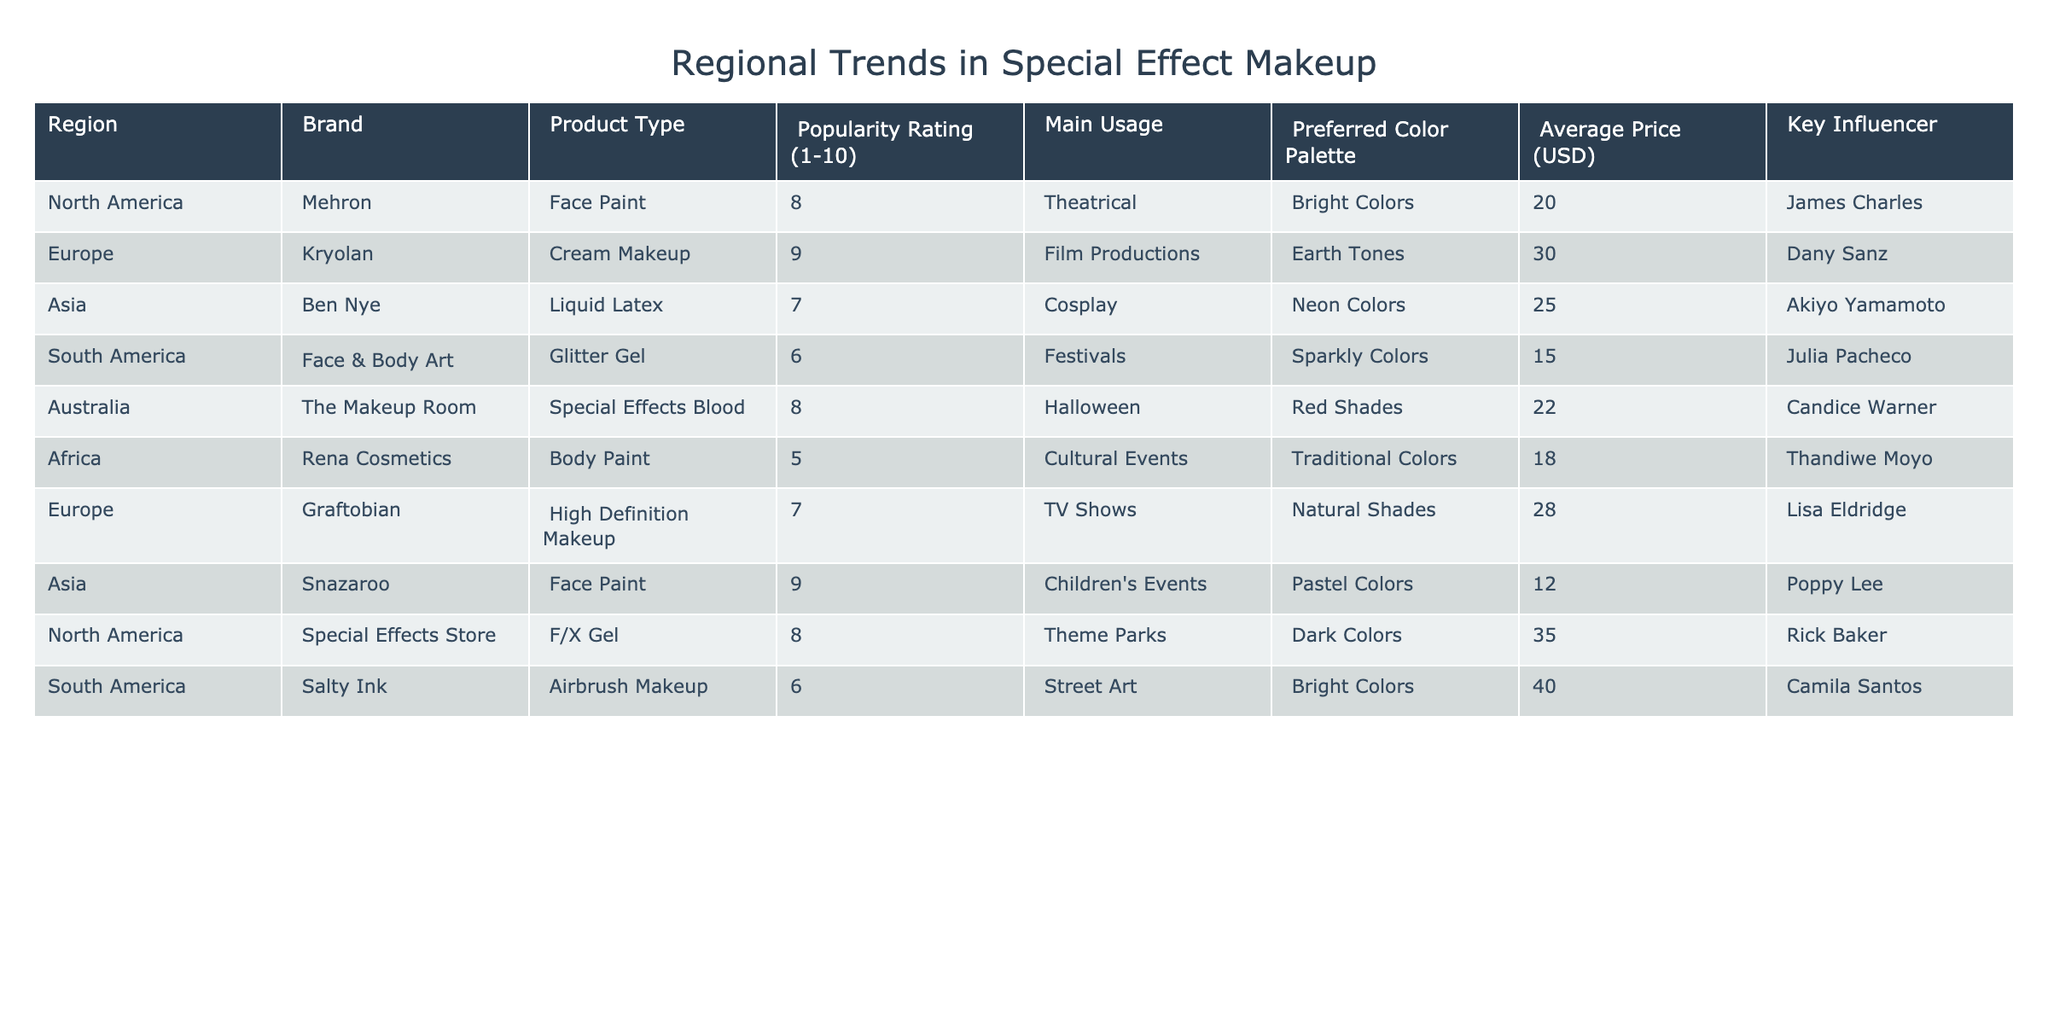What is the most popular product type in Europe? In Europe, the products listed are Kryolan (Cream Makeup) with a popularity rating of 9 and Graftobian (High Definition Makeup) with a rating of 7. Therefore, the most popular product type is Cream Makeup, with a rating of 9.
Answer: Cream Makeup Which region has the highest average price for special effect makeup products? To find the region with the highest average price, we look at the average prices: North America (27.5), Europe (29), Asia (18.5), South America (23), Australia (22), and Africa (18). The highest is Europe with an average price of 29 USD.
Answer: Europe Is there any region where the preferred color palette includes traditional colors? There is a product from Africa, Rena Cosmetics, that includes traditional colors as the preferred color palette. Therefore, the answer is yes.
Answer: Yes What are the top three brands in North America based on popularity rating? In North America, the brands listed are Mehron (8), Special Effects Store (8). There are no brands exceeding a rating of 8. The top three would therefore include Mehron and Special Effects Store, plus any additional brands if they were listed. Since only two are mentioned, the answer focuses on them.
Answer: Mehron and Special Effects Store Which main usage has the lowest popularity rating across all regions? The main usage related to the lowest popularity rating is Body Paint from Africa, with a rating of 5.
Answer: Cultural Events How do the popularity ratings of Ben Nye and Snazaroo compare? Ben Nye has a popularity rating of 7 for Liquid Latex, while Snazaroo has a rating of 9 for Face Paint. Snazaroo is rated higher than Ben Nye.
Answer: Snazaroo is rated higher Which region is most associated with the key influencer James Charles? The region associated with James Charles is North America. He is linked with the brand Mehron which has a popularity rating of 8.
Answer: North America What is the average popularity rating of products used at festivals? The products associated with festivals are Glitter Gel (6 from South America) and no other products mention festivals. Hence, the average is 6.
Answer: 6 Are there any products in Asia that have a higher than average rating (7) and what are they? Asia has Ben Nye with a rating of 7 and Snazaroo with a rating of 9. Snazaroo is the only one above 7 (rating 9).
Answer: Snazaroo What is the total number of products listed for each region? The regions and corresponding product counts are: North America (3), Europe (2), Asia (2), South America (2), Australia (1), Africa (1). Adding these gives a total of 11 products.
Answer: 11 Which brand is the most common in terms of the number of products listed per region? Each region has different numbers, with the brands having one or more entries. In this case, there’s no brand that appears multiple times across regions. The most common is therefore a tie based on their individual representation.
Answer: None 